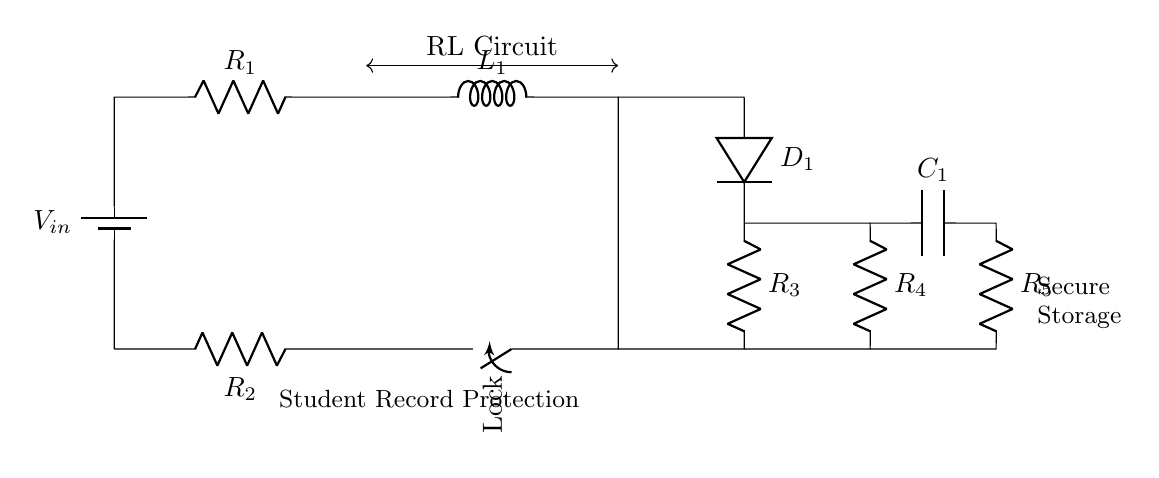What is the power source in the circuit? The circuit diagram shows a battery labeled as V_in, which serves as the power source. Therefore, V_in provides the necessary electrical energy for the operation of the circuit.
Answer: V_in What is the time constant of the RL circuit? The time constant for an RL circuit is calculated using the formula τ = L/R, where L is the inductance and R is the resistance. Since multiple resistors exist, the effective resistance must be determined first before calculating τ.
Answer: L/R Which components are in parallel? The circuit shows that the switch and resistor R_2 are connected in parallel to the rest of the components, as they share the same two endpoints. This indicates they are part of a parallel branch in the circuit.
Answer: Switch and R_2 What is the role of the diode in this circuit? The diode, labeled D_1, allows current to flow in one direction only, providing protection against reverse polarity. This ensures that the circuit operates correctly by preventing potential damage that could occur due to incorrect connections.
Answer: Protection What happens when the switch is open? When the switch is open, the current path is interrupted, preventing current from flowing through R_2. Consequently, any components downstream of the switch, including the load provided by the RL elements, will not receive any current, essentially disabling the circuit.
Answer: Circuit disabled 